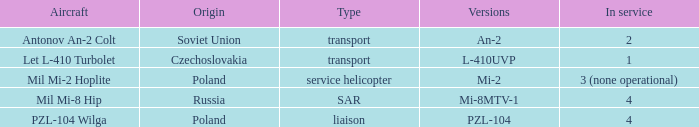Give me the full table as a dictionary. {'header': ['Aircraft', 'Origin', 'Type', 'Versions', 'In service'], 'rows': [['Antonov An-2 Colt', 'Soviet Union', 'transport', 'An-2', '2'], ['Let L-410 Turbolet', 'Czechoslovakia', 'transport', 'L-410UVP', '1'], ['Mil Mi-2 Hoplite', 'Poland', 'service helicopter', 'Mi-2', '3 (none operational)'], ['Mil Mi-8 Hip', 'Russia', 'SAR', 'Mi-8MTV-1', '4'], ['PZL-104 Wilga', 'Poland', 'liaison', 'PZL-104', '4']]} Can you provide the various forms of czechoslovakia? L-410UVP. 